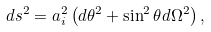<formula> <loc_0><loc_0><loc_500><loc_500>d s ^ { 2 } = a _ { i } ^ { 2 } \left ( d \theta ^ { 2 } + \sin ^ { 2 } \theta d \Omega ^ { 2 } \right ) ,</formula> 